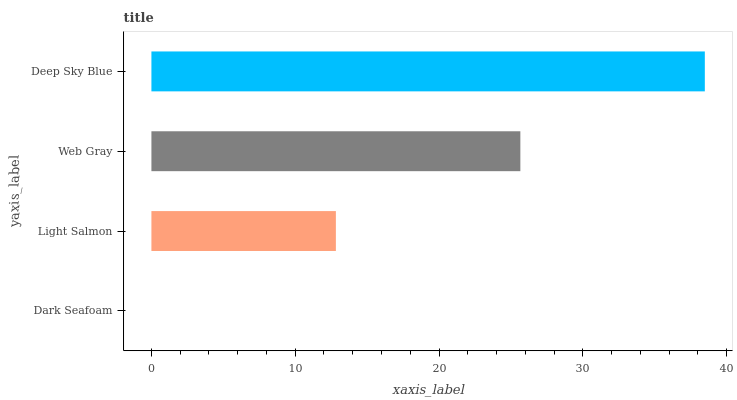Is Dark Seafoam the minimum?
Answer yes or no. Yes. Is Deep Sky Blue the maximum?
Answer yes or no. Yes. Is Light Salmon the minimum?
Answer yes or no. No. Is Light Salmon the maximum?
Answer yes or no. No. Is Light Salmon greater than Dark Seafoam?
Answer yes or no. Yes. Is Dark Seafoam less than Light Salmon?
Answer yes or no. Yes. Is Dark Seafoam greater than Light Salmon?
Answer yes or no. No. Is Light Salmon less than Dark Seafoam?
Answer yes or no. No. Is Web Gray the high median?
Answer yes or no. Yes. Is Light Salmon the low median?
Answer yes or no. Yes. Is Dark Seafoam the high median?
Answer yes or no. No. Is Deep Sky Blue the low median?
Answer yes or no. No. 